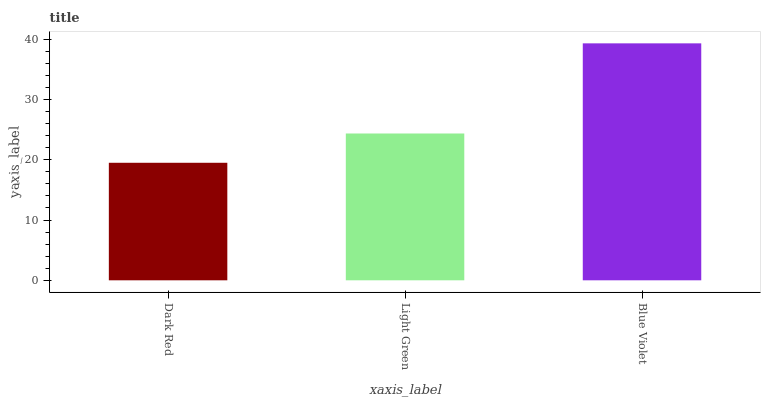Is Light Green the minimum?
Answer yes or no. No. Is Light Green the maximum?
Answer yes or no. No. Is Light Green greater than Dark Red?
Answer yes or no. Yes. Is Dark Red less than Light Green?
Answer yes or no. Yes. Is Dark Red greater than Light Green?
Answer yes or no. No. Is Light Green less than Dark Red?
Answer yes or no. No. Is Light Green the high median?
Answer yes or no. Yes. Is Light Green the low median?
Answer yes or no. Yes. Is Blue Violet the high median?
Answer yes or no. No. Is Blue Violet the low median?
Answer yes or no. No. 